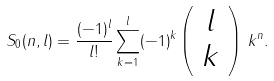Convert formula to latex. <formula><loc_0><loc_0><loc_500><loc_500>S _ { 0 } ( n , l ) = \frac { ( - 1 ) ^ { l } } { l ! } \sum _ { k = 1 } ^ { l } ( - 1 ) ^ { k } \left ( \begin{array} { c } l \\ k \end{array} \right ) \, k ^ { n } .</formula> 